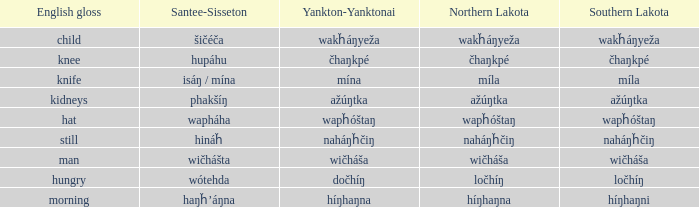Can you provide the english equivalent for the term haŋȟ'áŋna? Morning. 